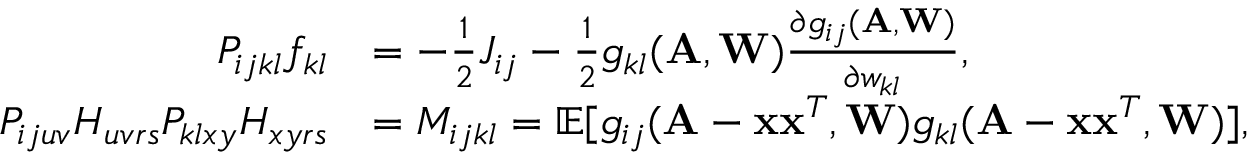<formula> <loc_0><loc_0><loc_500><loc_500>\begin{array} { r l } { P _ { i j k l } f _ { k l } } & { = - \frac { 1 } { 2 } J _ { i j } - \frac { 1 } { 2 } g _ { k l } ( \mathbf A , \mathbf W ) \frac { \partial g _ { i j } ( \mathbf A , \mathbf W ) } { \partial w _ { k l } } , } \\ { P _ { i j u v } H _ { u v r s } P _ { k l x y } H _ { x y r s } } & { = M _ { i j k l } = \mathbb { E } [ g _ { i j } ( \mathbf A - \mathbf x \mathbf x ^ { T } , \mathbf W ) g _ { k l } ( \mathbf A - \mathbf x \mathbf x ^ { T } , \mathbf W ) ] , } \end{array}</formula> 